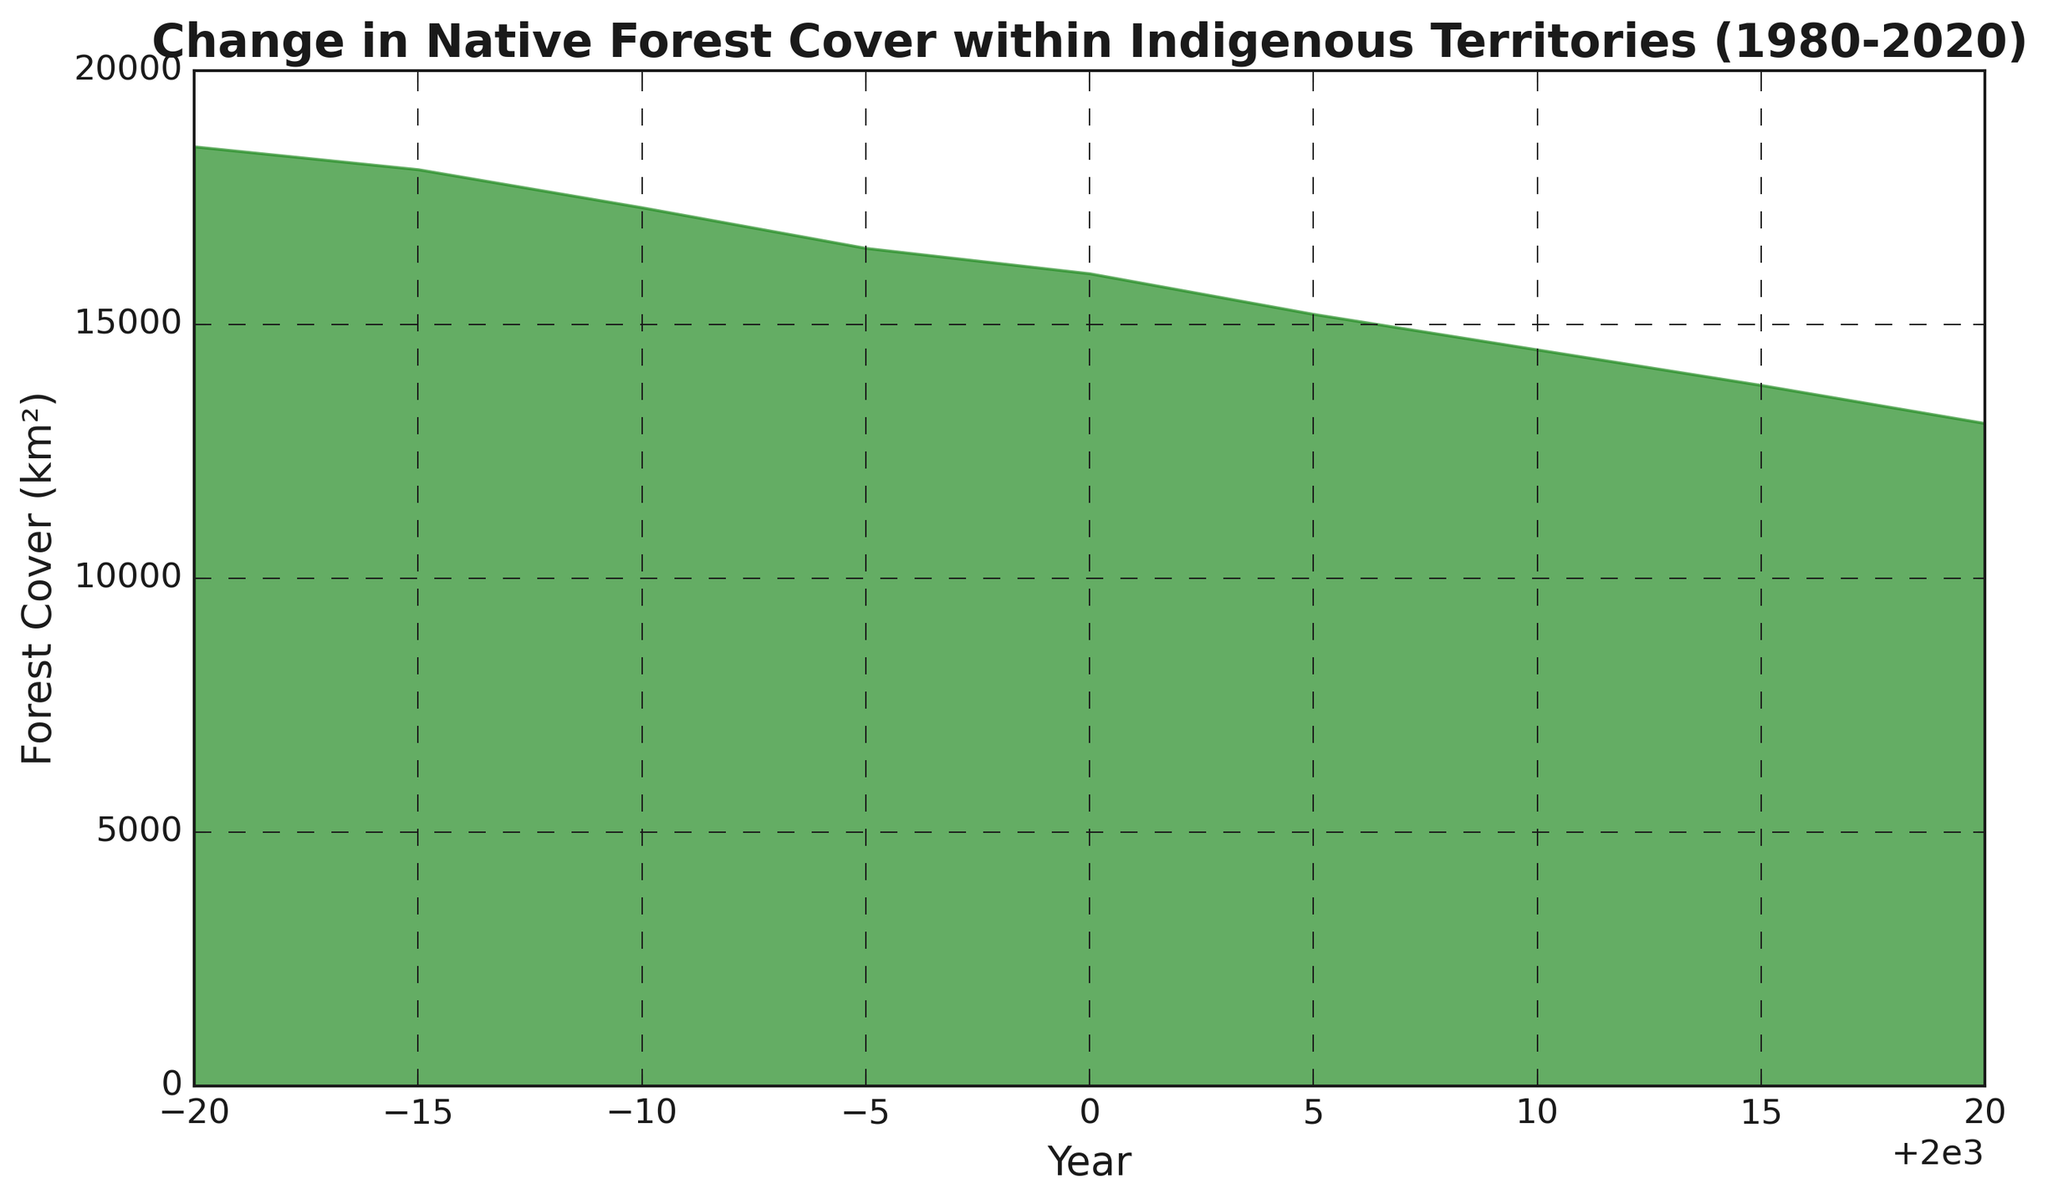What is the first recorded year in the chart? The first recorded year is the initial point on the x-axis of the chart.
Answer: 1980 What is the difference in forest cover between 1980 and 2020? To find the difference, subtract the forest cover in 2020 from the forest cover in 1980: 18500 km² - 13050 km² = 5450 km².
Answer: 5450 km² In which year did the forest cover decrease the most compared to the previous recorded year? Evaluate the difference between consecutive years and identify the largest negative change. Between 2000 and 2005, the difference is the greatest: 16000 km² (2000) - 15200 km² (2005) = 800 km².
Answer: 2005 Between which years did the forest cover fall below 15000 km²? Identify the year when the forest cover first falls below 15000 km². The year immediately preceding 2010 already has more than 15000 km², and 2010 shows a forest cover of 14500 km².
Answer: 2010 How does the forest cover in 1990 compare to 2000? Compare the values: 17300 km² (1990) is greater than 16000 km² (2000).
Answer: Greater in 1990 What is the approximate average annual decrease in forest cover over the entire period from 1980 to 2020? First, find the total decrease: 18500 km² (1980) - 13050 km² (2020) = 5450 km². There are 40 years between 1980 and 2020. Divide the total decrease by the number of years to get the annual average decrease: 5450 km² / 40 = approximately 136.25 km² per year.
Answer: Approximately 136.25 km² per year Which five-year period saw the smallest decrease in forest cover? Calculate the decrease for each five-year period and compare them. The smallest decrease is between 1980 and 1985: 18500 km² (1980) - 18050 km² (1985) = 450 km².
Answer: 1980-1985 How does the forest cover change from 2010 to 2015 visually compare to the change from 2015 to 2020? Visually observe and compare the steepness and length of the slopes between these periods. There is a similar slope in the positive downward direction from 2010 to 2015 and from 2015 to 2020.
Answer: Similar downward trends What is the visual representation color used in the area chart? Identify the color prominently filling the area under the curve in the chart.
Answer: Forest green What trend can be observed in the forest cover from 1980 to 2020? Examine the overall shape and direction of the area in the chart. The trend shows a consistent decrease in forest cover over this period.
Answer: Consistent decrease 